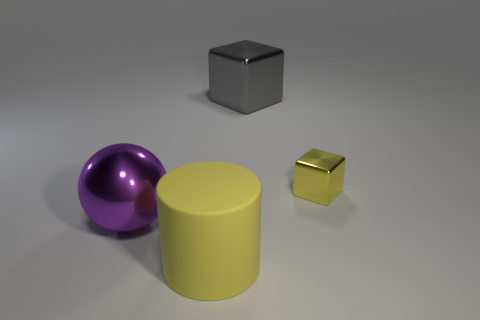Does the big matte thing have the same color as the small metal cube?
Offer a very short reply. Yes. Does the block in front of the large gray object have the same color as the large cylinder?
Your answer should be very brief. Yes. What shape is the other matte object that is the same color as the small object?
Offer a terse response. Cylinder. Is there a block that has the same color as the large matte thing?
Your answer should be compact. Yes. There is a rubber thing that is the same color as the small cube; what size is it?
Your answer should be very brief. Large. How many other things are the same size as the yellow cube?
Your answer should be very brief. 0. How many objects are behind the rubber thing and to the left of the big shiny cube?
Ensure brevity in your answer.  1. What color is the big metal thing that is on the left side of the yellow object on the left side of the cube that is right of the big metal cube?
Make the answer very short. Purple. How many other objects are the same shape as the tiny yellow object?
Make the answer very short. 1. There is a big metallic object that is on the left side of the large cube; is there a cylinder that is right of it?
Keep it short and to the point. Yes. 